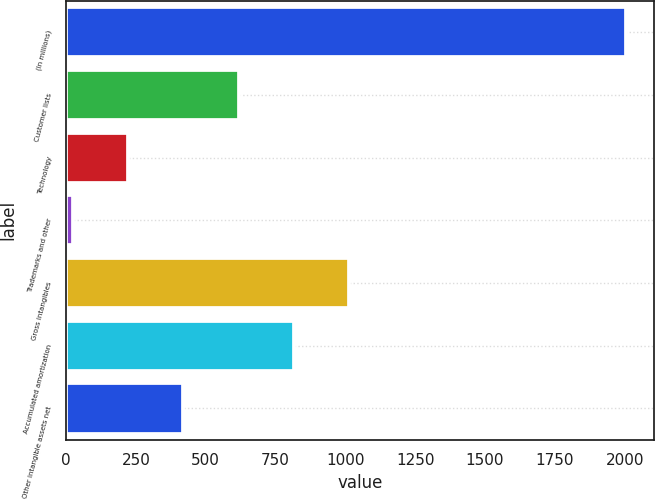Convert chart. <chart><loc_0><loc_0><loc_500><loc_500><bar_chart><fcel>(In millions)<fcel>Customer lists<fcel>Technology<fcel>Trademarks and other<fcel>Gross intangibles<fcel>Accumulated amortization<fcel>Other intangible assets net<nl><fcel>2004<fcel>617.86<fcel>221.82<fcel>23.8<fcel>1013.9<fcel>815.88<fcel>419.84<nl></chart> 